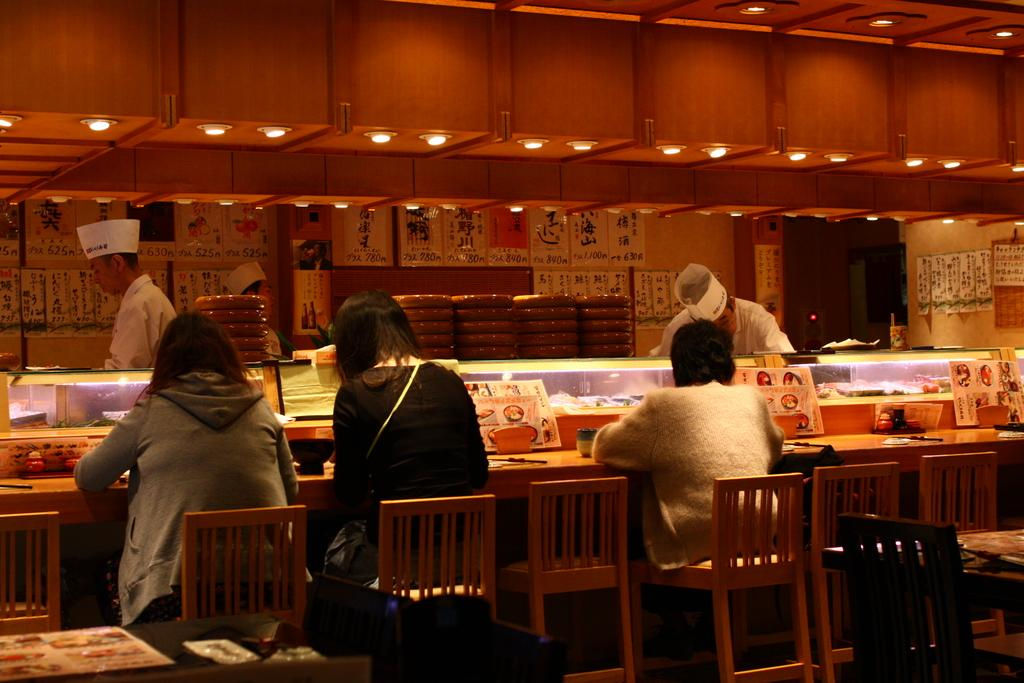How many people are sitting at the table in the image? There are 3 persons sitting at the table in the image. How many people are standing in the background? There are 3 persons standing in the background in the image. What can be seen on the wall in the image? There are posters on the wall in the image. What can be seen providing illumination in the image? There are lights visible in the image. What type of good-bye message is written on the posters in the image? There is no good-bye message present on the posters in the image. Can you see any trains in the image? There are no trains visible in the image. Is there a tank present in the image? There is no tank present in the image. 